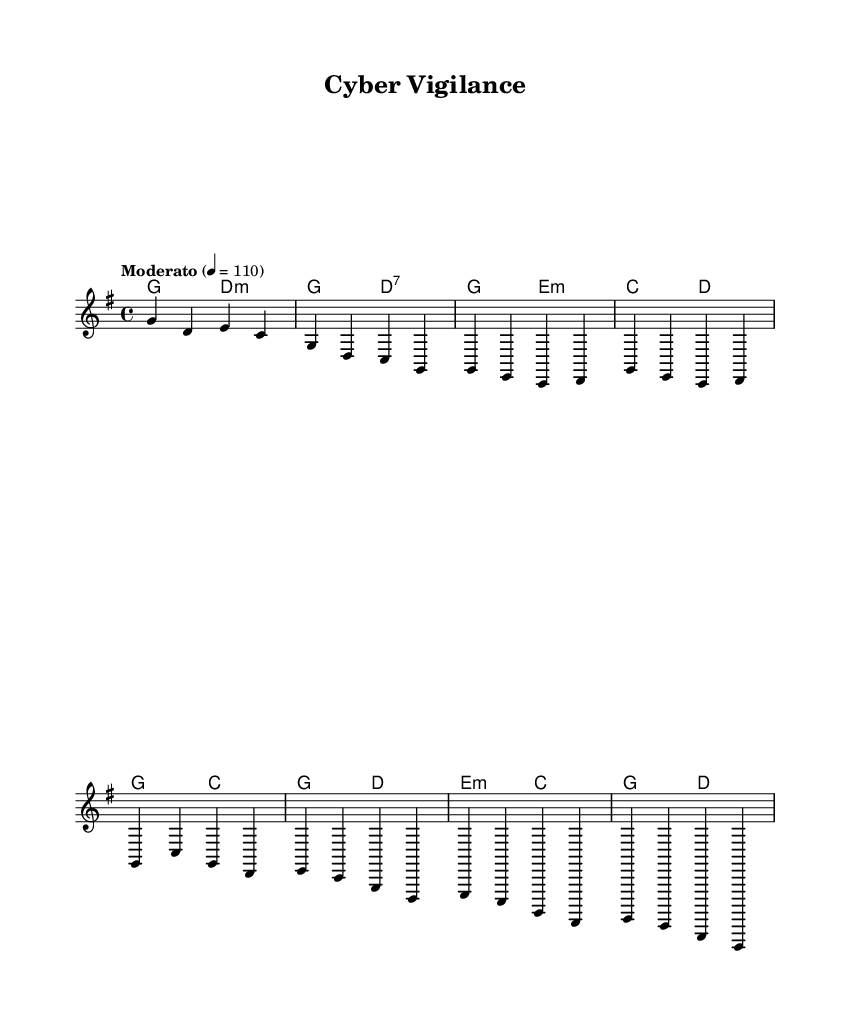What is the key signature of this music? The key signature shows one sharp, indicating that the key is G major. G major has an F sharp, which is evident in the notes.
Answer: G major What is the time signature of this music? The time signature is indicated as 4/4, which means there are four beats in each measure and a quarter note receives one beat. This is commonly known as "common time."
Answer: 4/4 What is the tempo marking for this piece? The tempo marking is indicated as "Moderato", which typically suggests a moderate speed, often around 108 to 120 beats per minute. The exact marking also specifies a tempo of 110 beats per minute.
Answer: Moderato How many measures are in the verse section? The verse section consists of two lines, with each line containing two measures, totaling four measures for the verse.
Answer: 4 What are the primary chords used in the chorus? The chords used in the chorus are G major and D major. The G chord is the tonic, while the D chord is the dominant chord in this context.
Answer: G and D Which musical element is primarily used to convey the theme of national security? The lyrics, as they aren’t directly visible, usually encapsulate themes related to vigilance, defense, or patriotism, which are often reflected in the melody’s intensity and progression.
Answer: Melody What is the overall mood created by the harmonies in this piece? The harmonies suggest a strong and resolute mood, typical of patriotic anthems that emphasize strength and unity, using major chords to inspire a sense of nationalism.
Answer: Strong 